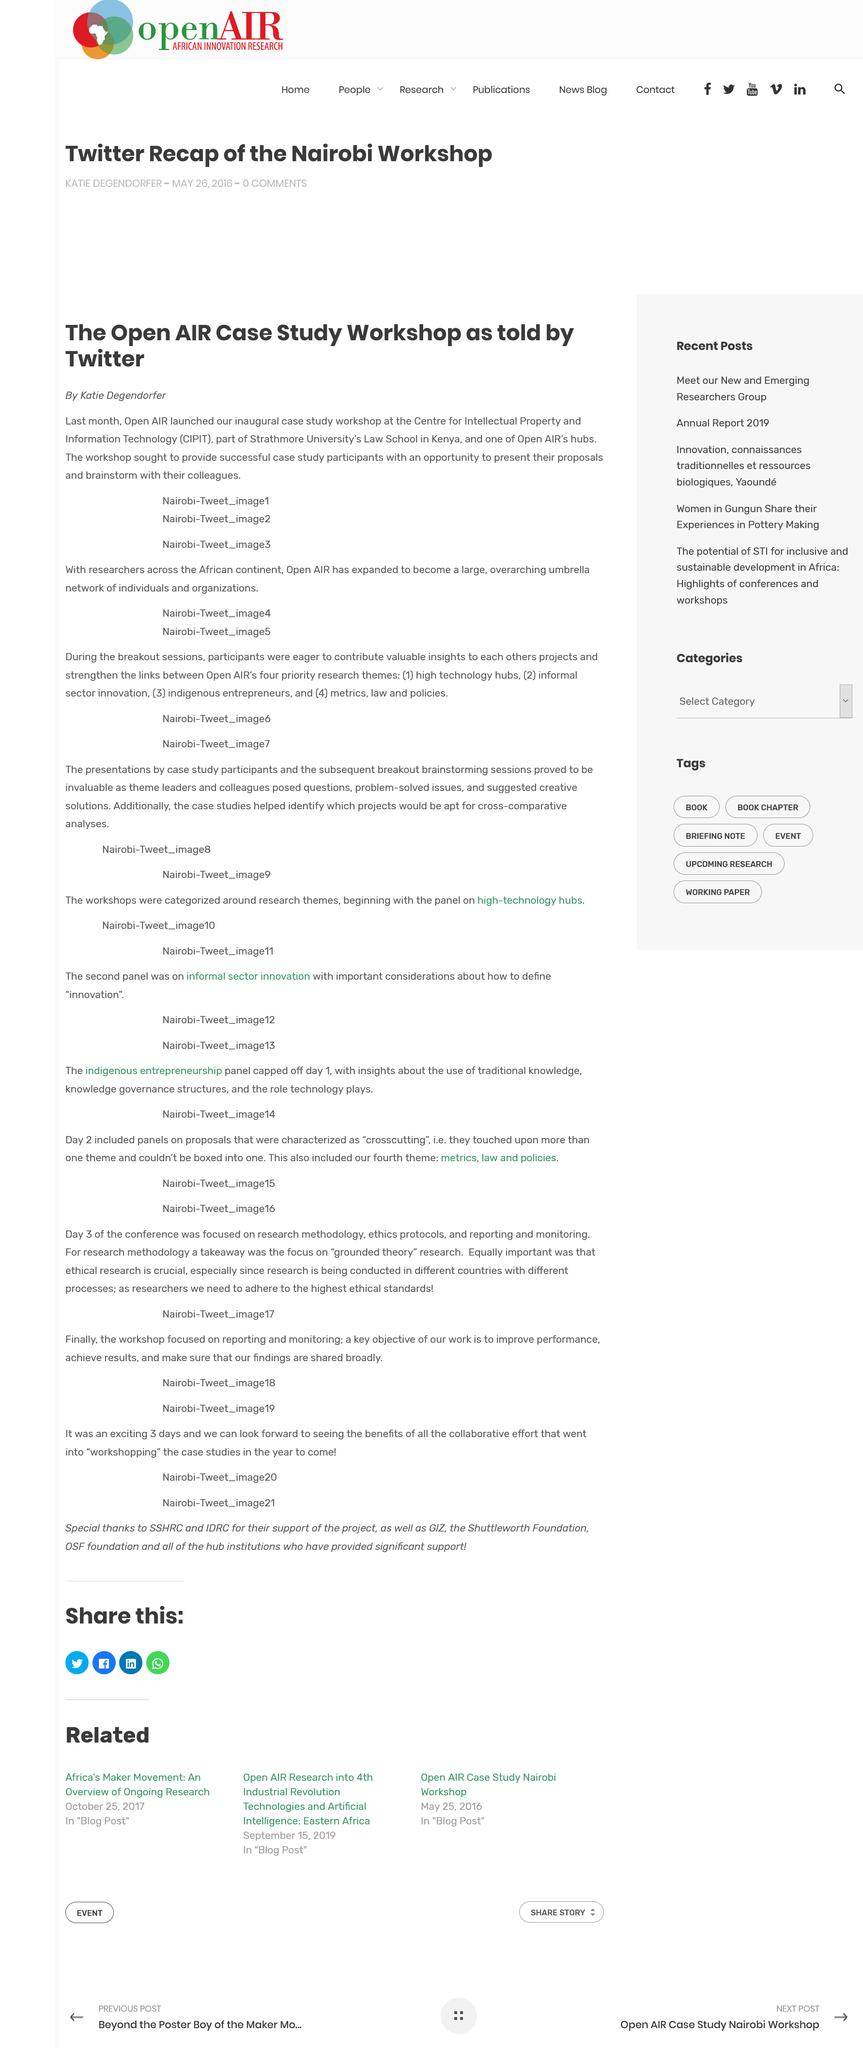Specify some key components in this picture. The workshop enabled participants to present their proposals and brainstorm with their colleagues. Katie Degendorfer wrote the article. OpenAIR's workshop was held at the Centre for Intellectual Property and Information Technology (CIPIT). 